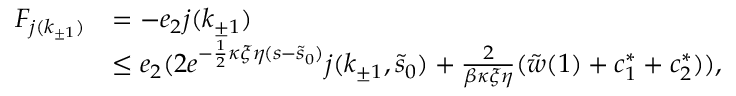Convert formula to latex. <formula><loc_0><loc_0><loc_500><loc_500>\begin{array} { r l } { F _ { j ( k _ { \pm 1 } ) } } & { = - e _ { 2 } j ( k _ { \pm 1 } ) } \\ & { \leq e _ { 2 } ( 2 e ^ { - \frac { 1 } { 2 } \kappa \xi \eta ( s - \tilde { s } _ { 0 } ) } j ( k _ { \pm 1 } , \tilde { s } _ { 0 } ) + \frac { 2 } \beta \kappa \xi \eta } ( \tilde { w } ( 1 ) + c _ { 1 } ^ { \ast } + c _ { 2 } ^ { \ast } ) ) , } \end{array}</formula> 